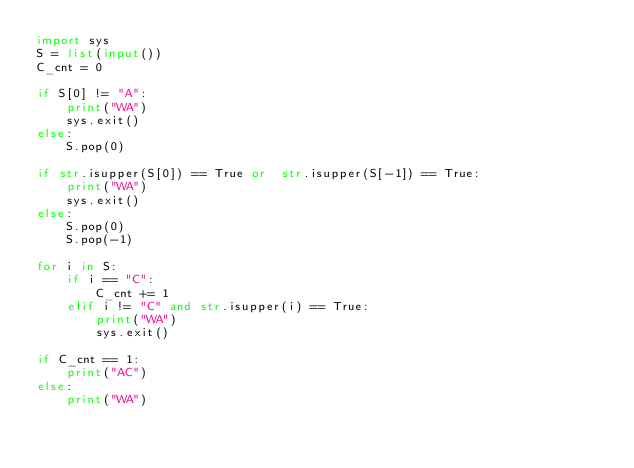<code> <loc_0><loc_0><loc_500><loc_500><_Python_>import sys
S = list(input())
C_cnt = 0

if S[0] != "A":
    print("WA")
    sys.exit()
else:
    S.pop(0)

if str.isupper(S[0]) == True or  str.isupper(S[-1]) == True:
    print("WA")
    sys.exit()
else:
    S.pop(0)
    S.pop(-1)

for i in S:
    if i == "C":
        C_cnt += 1
    elif i != "C" and str.isupper(i) == True:
        print("WA")
        sys.exit()

if C_cnt == 1:
    print("AC")
else:
    print("WA")</code> 